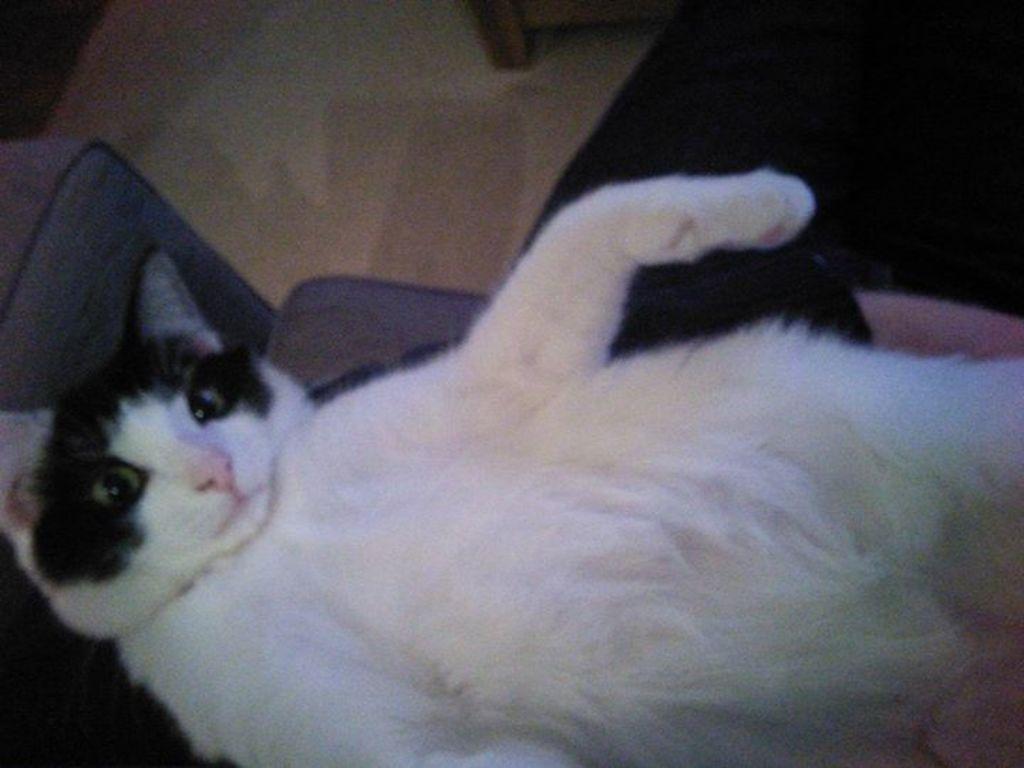Can you describe this image briefly? In this picture there is a white cat lying on the sofa. At the back there is a chair, at the bottom there is a mat. 